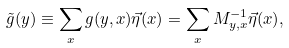Convert formula to latex. <formula><loc_0><loc_0><loc_500><loc_500>\tilde { g } ( y ) \equiv \sum _ { x } g ( y , x ) \vec { \eta } ( x ) = \sum _ { x } M ^ { - 1 } _ { y , x } \vec { \eta } ( x ) ,</formula> 